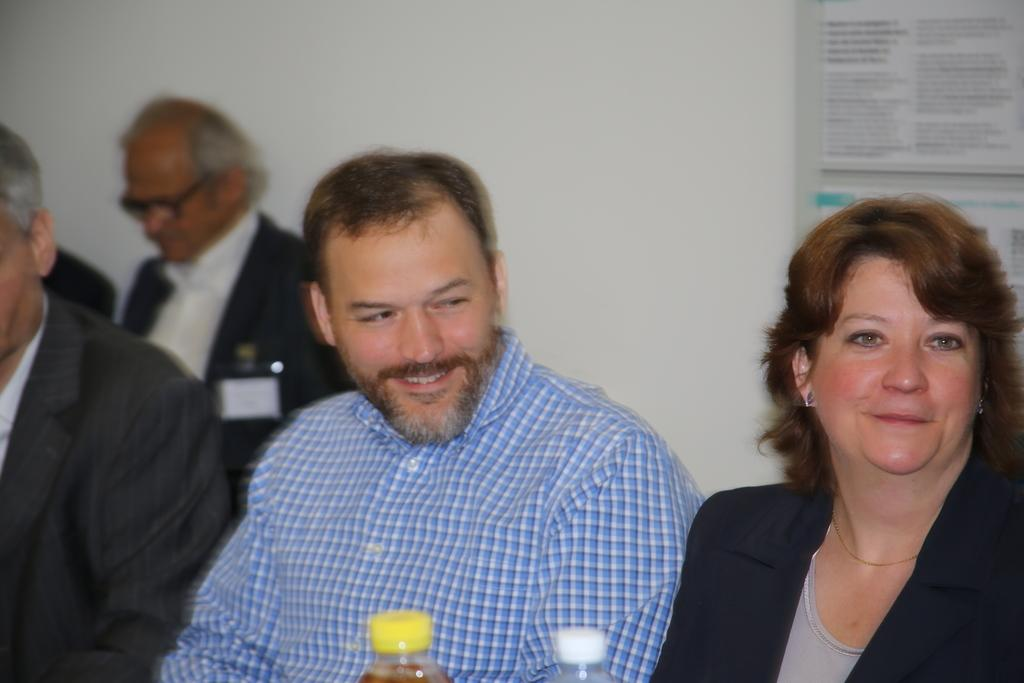How many persons are visible in the image? There are persons in the image, but the exact number is not specified. What is the facial expression of the persons in the image? The persons in the image are smiling. What objects can be seen in the image besides the persons? There are bottles in the image. What is present on the wall in the background? There is a frame on the wall in the background. What is written on the frame? There is text written on the frame. Can you describe the person in the background? There is a person in the background, but no specific details are provided. What type of jeans is the quartz wearing in the image? There is no mention of jeans or quartz in the image, so this question cannot be answered. 